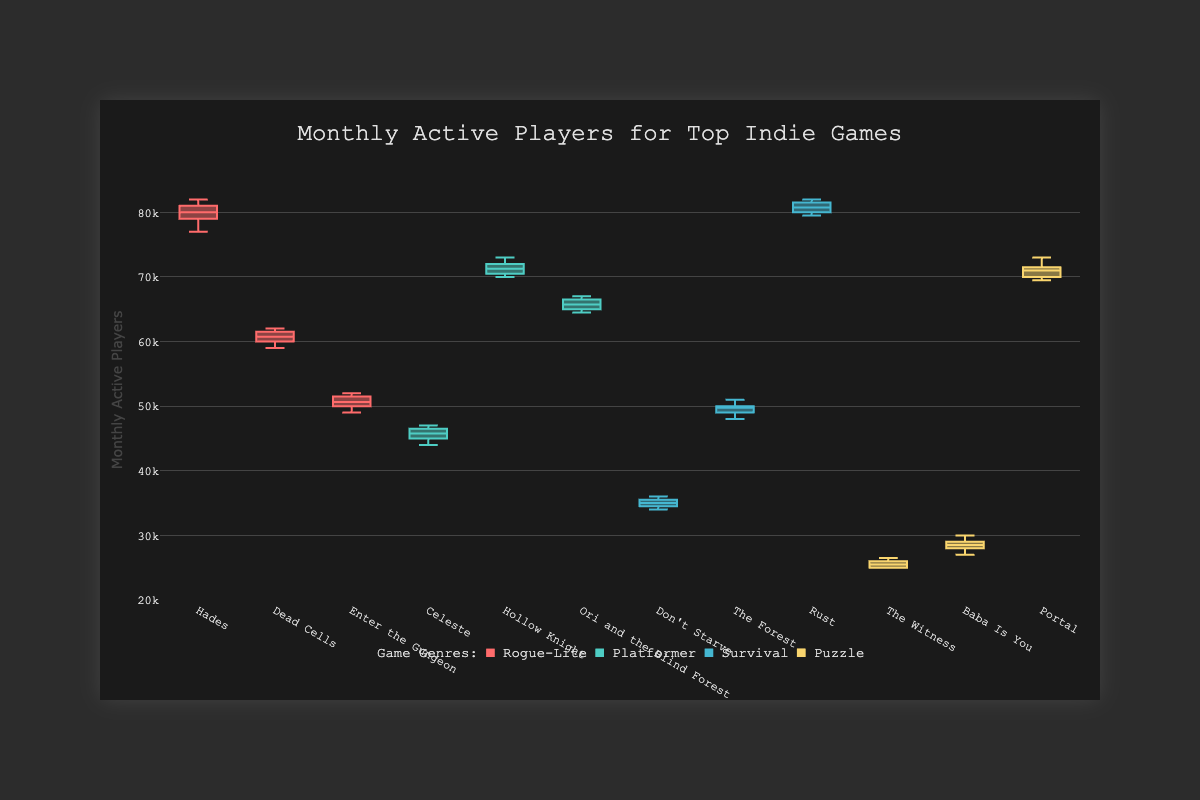Which game has the highest median monthly active players in the Rogue-Lite genre? The box plots show the median of each dataset as a horizontal line within the box. In the Rogue-Lite genre, Hades has the highest median monthly active players.
Answer: Hades Comparing all genres, which game shows the largest interquartile range (IQR), and what is the reason? The interquartile range (IQR) is the range between the first quartile (25th percentile) and the third quartile (75th percentile) within each box plot. Among all games, Rust shows the largest IQR because the length of the box (from Q1 to Q3) is the longest in Rust's plot.
Answer: Rust What is the approximate range of monthly active players for Celeste? The range is determined by the span of the vertical line (whiskers) and any outliers. From the box plot, Celeste has a minimum value around 44000 and a maximum around 47000.
Answer: 44000 to 47000 Which game has more monthly active players on average: Don't Starve or Baba Is You? To find the average, note that the middle of the data points often represents the average. From the box plot, Baba Is You has a higher median and a higher average data point concentration compared to Don't Starve.
Answer: Baba Is You How does the variability of Hades compare to Dead Cells in terms of monthly active players? Variability can be assessed by looking at the spread of the box and whiskers. The box plot for Hades shows a greater spread (including the IQR and whiskers) indicating higher variability compared to Dead Cells.
Answer: Higher What is the median monthly active players for Portal? The median is represented by the line inside the box. For Portal, the median is around 71500.
Answer: 71500 Which genre has the game with the lowest monthly active players, and which game is it? The Puzzle genre has the game with the lowest monthly active players, which is The Witness.
Answer: The Witness Compare the range of monthly active players for Rust and Portal. Which one has a broader range? Rust and Portal's ranges can be visually assessed by the length of their whiskers and any outliers. Rust has a broader range, extending from about 79500 to 82000, compared to Portal's range extending roughly from 69500 to 73000.
Answer: Rust What are the monthly active player counts for the game with the smallest spread within the Platformer genre? The smallest spread indicates the smallest IQR and whiskers span for the game. Ori and the Blind Forest has the smallest spread within the genre. Its counts are between around 64500 to 67000.
Answer: 64500 to 67000 